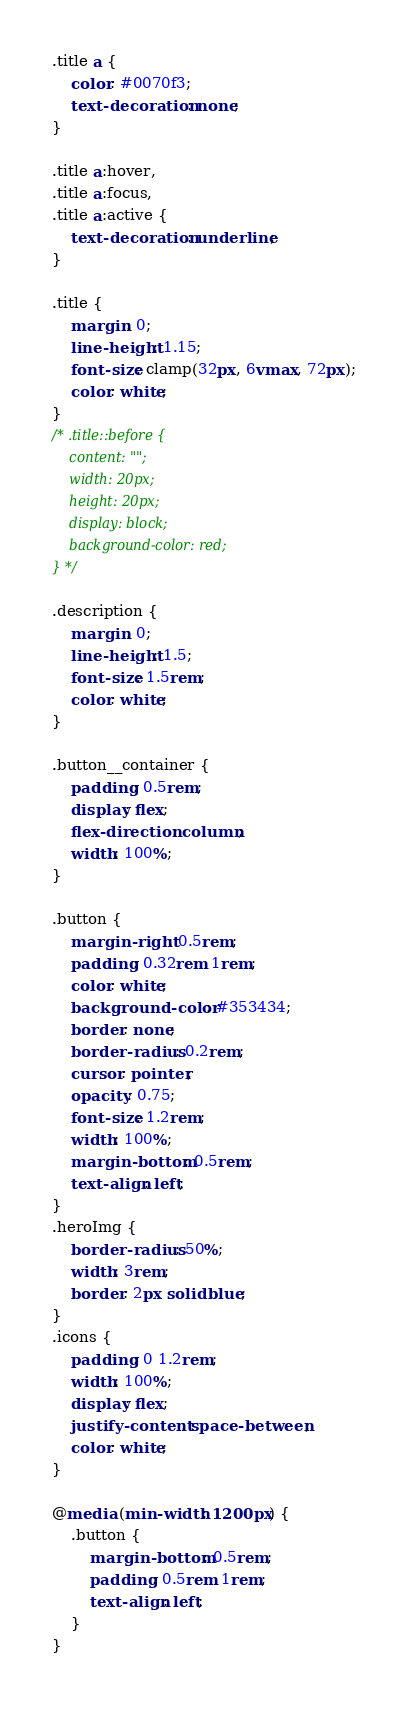<code> <loc_0><loc_0><loc_500><loc_500><_CSS_>.title a {
    color: #0070f3;
    text-decoration: none;
}

.title a:hover,
.title a:focus,
.title a:active {
    text-decoration: underline;
}

.title {
    margin: 0;
    line-height: 1.15;
    font-size: clamp(32px, 6vmax, 72px);
    color: white;
}
/* .title::before {
    content: "";
    width: 20px;
    height: 20px;
    display: block;
    background-color: red;
} */

.description {
    margin: 0;
    line-height: 1.5;
    font-size: 1.5rem;
    color: white;
}

.button__container {
    padding: 0.5rem;
    display: flex;
    flex-direction: column;
    width: 100%;
}

.button {
    margin-right: 0.5rem;
    padding: 0.32rem 1rem;
    color: white;
    background-color: #353434;
    border: none;
    border-radius: 0.2rem;
    cursor: pointer;
    opacity: 0.75;
    font-size: 1.2rem;
    width: 100%;
    margin-bottom: 0.5rem;
    text-align: left;
}
.heroImg {
    border-radius: 50%;
    width: 3rem;
    border: 2px solid blue;
}
.icons {
    padding: 0 1.2rem;
    width: 100%;
    display: flex;
    justify-content: space-between;
    color: white;
}

@media (min-width: 1200px) {
    .button {
        margin-bottom: 0.5rem;
        padding: 0.5rem 1rem;
        text-align: left;
    }
}
</code> 